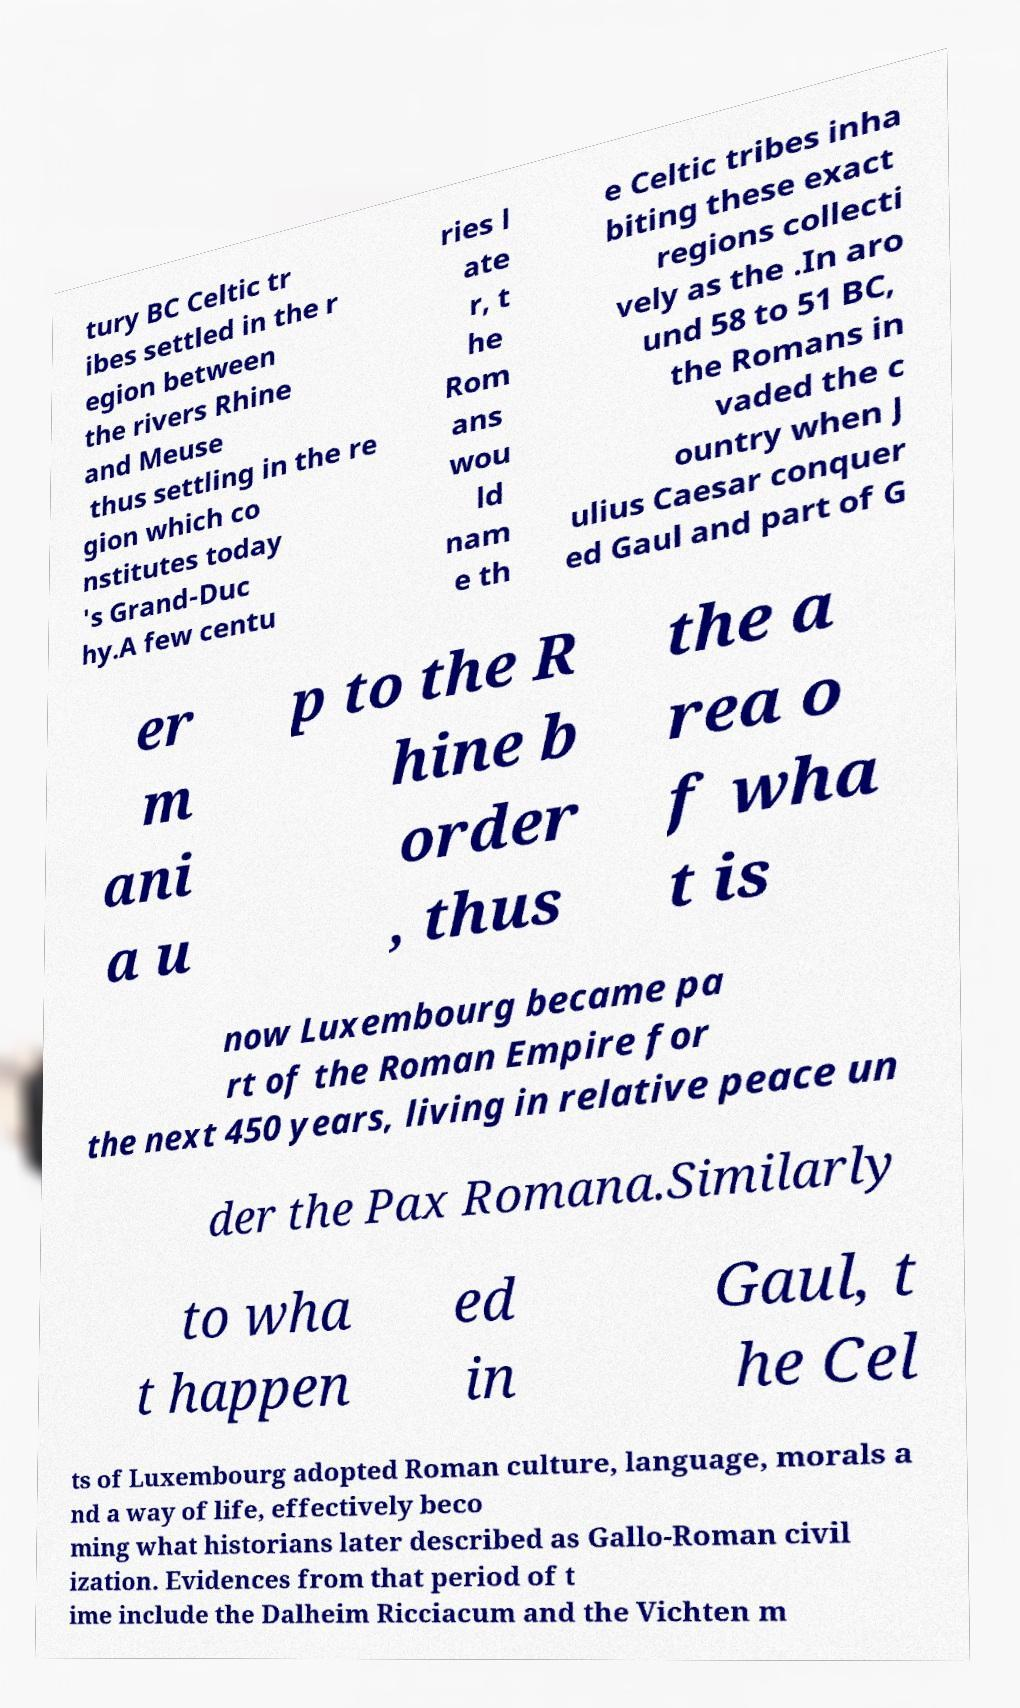Please identify and transcribe the text found in this image. tury BC Celtic tr ibes settled in the r egion between the rivers Rhine and Meuse thus settling in the re gion which co nstitutes today 's Grand-Duc hy.A few centu ries l ate r, t he Rom ans wou ld nam e th e Celtic tribes inha biting these exact regions collecti vely as the .In aro und 58 to 51 BC, the Romans in vaded the c ountry when J ulius Caesar conquer ed Gaul and part of G er m ani a u p to the R hine b order , thus the a rea o f wha t is now Luxembourg became pa rt of the Roman Empire for the next 450 years, living in relative peace un der the Pax Romana.Similarly to wha t happen ed in Gaul, t he Cel ts of Luxembourg adopted Roman culture, language, morals a nd a way of life, effectively beco ming what historians later described as Gallo-Roman civil ization. Evidences from that period of t ime include the Dalheim Ricciacum and the Vichten m 